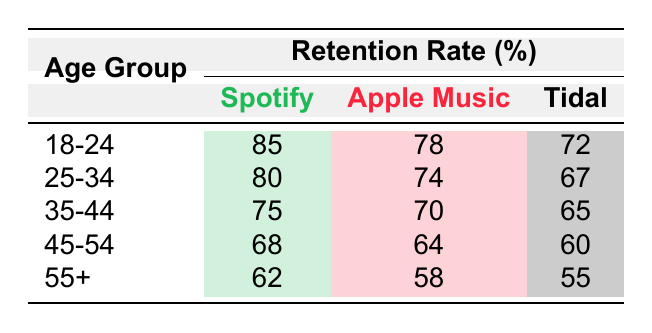What is the retention rate for Spotify in the age group 18-24? The table shows that the retention rate for Spotify in the age group 18-24 is listed directly under that category, which is 85.
Answer: 85 Which music platform has the highest retention rate for the 25-34 age group? By comparing the retention rates for Spotify (80), Apple Music (74), and Tidal (67) in the 25-34 age group, we see that Spotify has the highest rate at 80.
Answer: Spotify What is the average retention rate for Apple Music across all age groups? The retention rates for Apple Music in the age groups are 78, 74, 70, 64, and 58. Adding these values gives 364, and dividing by 5 (the number of groups) results in an average retention rate of 72.8.
Answer: 72.8 Is the retention rate for Tidal in the age group 35-44 greater than that in the age group 45-54? The retention rate for Tidal in the 35-44 age group is 65, while in the 45-54 age group it is 60. Since 65 is greater than 60, the statement is true.
Answer: Yes What is the difference in retention rate between Spotify and Tidal for the age group 55+? The retention rates for Spotify and Tidal in the 55+ age group are 62 and 55, respectively. The difference between them is calculated as 62 - 55, which equals 7.
Answer: 7 Which age group has the lowest retention rate for Apple Music? Looking at the retention rates for Apple Music, the values are 78 (18-24), 74 (25-34), 70 (35-44), 64 (45-54), and 58 (55+). The lowest value is 58, which corresponds to the 55+ age group.
Answer: 55+ What is the total retention rate for all platforms in the age group 45-54? For the age group 45-54, the retention rates are 68 (Spotify) + 64 (Apple Music) + 60 (Tidal). Adding these rates together results in 68 + 64 + 60 = 192.
Answer: 192 How do the retention rates for the 35-44 age group compare to those of the 25-34 age group for Spotify? The retention rate for Spotify in the 35-44 age group is 75, while in the 25-34 age group it is 80. The age group 25-34 has a higher retention rate by 5 (80 - 75).
Answer: 5 